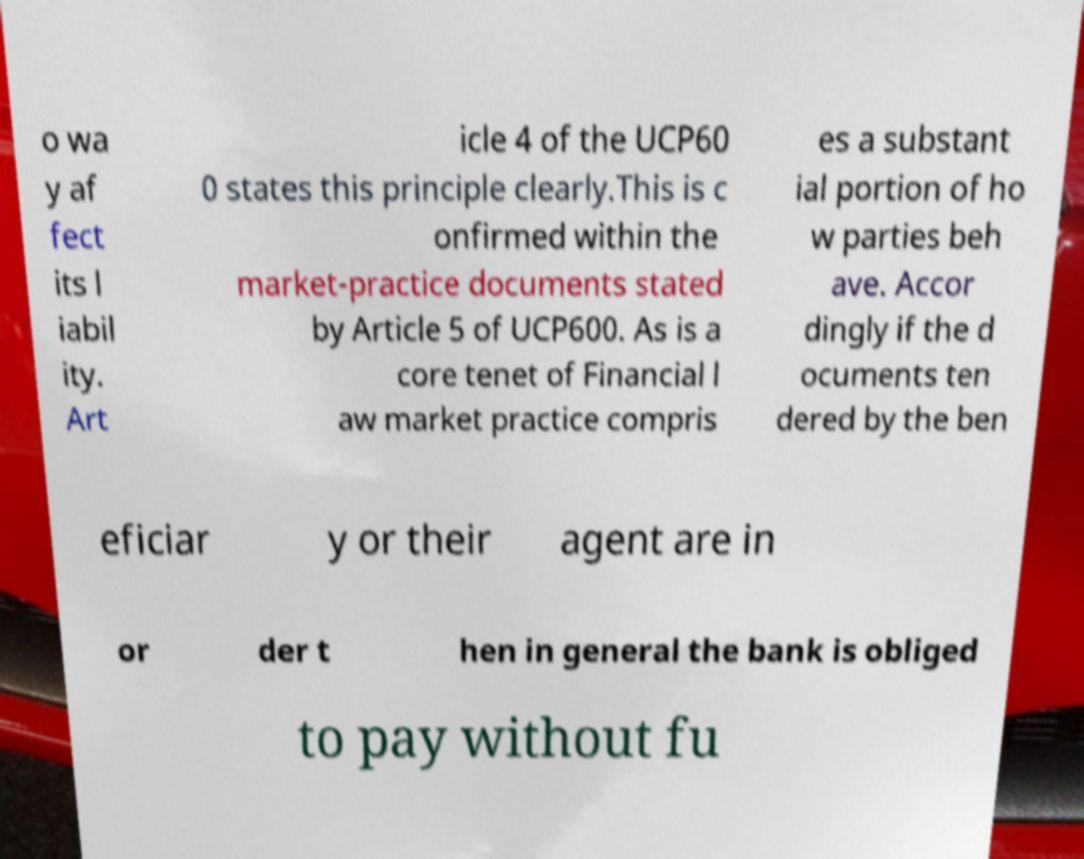I need the written content from this picture converted into text. Can you do that? o wa y af fect its l iabil ity. Art icle 4 of the UCP60 0 states this principle clearly.This is c onfirmed within the market-practice documents stated by Article 5 of UCP600. As is a core tenet of Financial l aw market practice compris es a substant ial portion of ho w parties beh ave. Accor dingly if the d ocuments ten dered by the ben eficiar y or their agent are in or der t hen in general the bank is obliged to pay without fu 